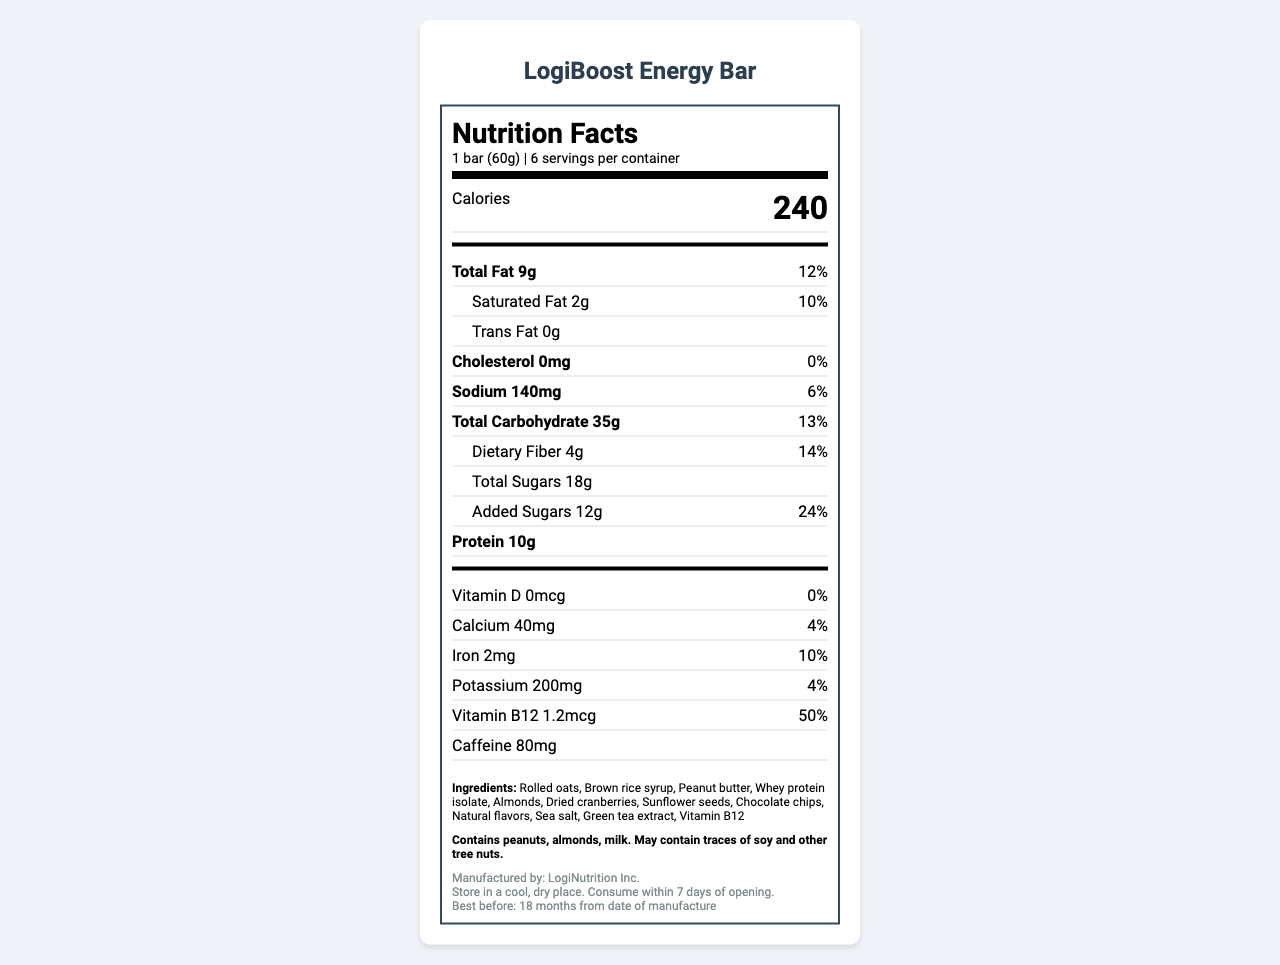what is the serving size of the LogiBoost Energy Bar? The serving size is listed at the top of the nutrition label as "1 bar (60g)".
Answer: 1 bar (60g) how many servings are there per container? The servings per container count is provided next to the serving size at the beginning of the nutrition facts section.
Answer: 6 how many calories are in a single serving of the LogiBoost Energy Bar? The calorie count is prominently displayed in the nutrition facts section.
Answer: 240 what is the amount of saturated fat per serving? The amount of saturated fat is listed under the Total Fat section in the label.
Answer: 2g what is the daily value percentage for added sugars? The daily value percentage for added sugars is listed under the Total Sugars section as 24%.
Answer: 24% how much protein is in one LogiBoost Energy Bar? The protein content per serving is listed toward the end of the nutrient table as 10g.
Answer: 10g how much caffeine does the energy bar contain? The caffeine content is mentioned at the end of the nutrient table as 80mg.
Answer: 80mg what allergens are present in the LogiBoost Energy Bar? The allergen info section specifies the allergens present in the product.
Answer: peanuts, almonds, milk (may contain traces of soy and other tree nuts) what is the best before date for the LogiBoost Energy Bar? The best before date information is provided in the manufacturer info section as "18 months from date of manufacture".
Answer: 18 months from date of manufacture what is the primary ingredient in the LogiBoost Energy Bar? The ingredients list starts with rolled oats, indicating it is the primary ingredient.
Answer: Rolled oats how much sodium is present in a single serving? A. 50mg B. 140mg C. 200mg D. 300mg The sodium content is listed as 140mg under the Sodium section of the nutrition label.
Answer: B how much dietary fiber does one LogiBoost Energy Bar contain? A. 2g B. 4g C. 8g D. 10g The dietary fiber amount per serving is specified as 4g under the carbohydrate section.
Answer: B is the LogiBoost Energy Bar vegan? The document does not provide enough information to determine if the bar is vegan, as it contains milk and has a possible cross-contamination with other tree nuts and soy.
Answer: Cannot be determined does the product contain any cholesterol? The cholesterol content is listed as 0mg, indicating that the product contains no cholesterol.
Answer: No provide a summary of the LogiBoost Energy Bar's nutrition facts and other important information. This summary encapsulates the key information from the nutrition facts label, including nutrient contents, ingredients, allergens, manufacturer details, and storage instructions.
Answer: The LogiBoost Energy Bar contains 240 calories per serving and comes in a container with 6 servings. Each bar provides 9g of total fat, 2g of saturated fat, and 0g of trans fat. It has no cholesterol and 140mg of sodium. The total carbohydrate content is 35g, with 4g of dietary fiber and 18g of sugars, including 12g of added sugars. The protein content is notable at 10g per bar. It also contains 80mg of caffeine. The bar includes several vitamins and minerals, such as 0mcg of Vitamin D, 40mg of Calcium, 2mg of Iron, 200mg of Potassium, and 1.2mcg of Vitamin B12. Ingredients listed include rolled oats, brown rice syrup, peanut butter, and other items. The product has specific allergen information indicating the presence of peanuts, almonds, and milk. It is manufactured by LogiNutrition Inc., with storage instructions to keep it in a cool, dry place and consume within 7 days of opening. The product is best before 18 months from the date of manufacture. 